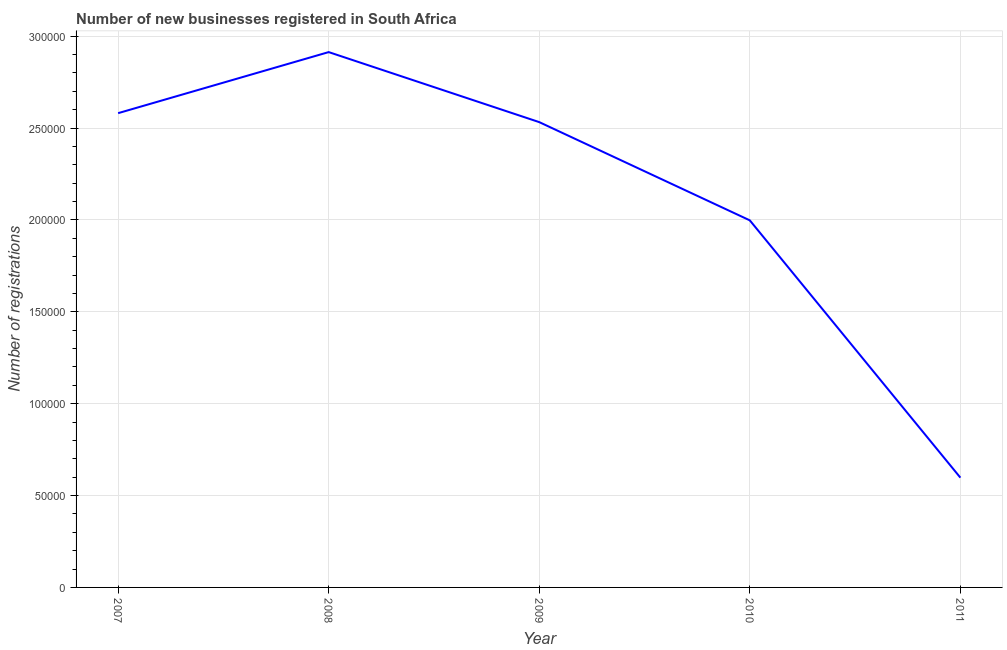What is the number of new business registrations in 2011?
Offer a terse response. 5.97e+04. Across all years, what is the maximum number of new business registrations?
Make the answer very short. 2.91e+05. Across all years, what is the minimum number of new business registrations?
Offer a terse response. 5.97e+04. What is the sum of the number of new business registrations?
Provide a succinct answer. 1.06e+06. What is the difference between the number of new business registrations in 2008 and 2010?
Your response must be concise. 9.16e+04. What is the average number of new business registrations per year?
Provide a short and direct response. 2.12e+05. What is the median number of new business registrations?
Give a very brief answer. 2.53e+05. In how many years, is the number of new business registrations greater than 280000 ?
Your answer should be compact. 1. What is the ratio of the number of new business registrations in 2007 to that in 2009?
Make the answer very short. 1.02. Is the number of new business registrations in 2007 less than that in 2009?
Keep it short and to the point. No. Is the difference between the number of new business registrations in 2009 and 2011 greater than the difference between any two years?
Ensure brevity in your answer.  No. What is the difference between the highest and the second highest number of new business registrations?
Provide a short and direct response. 3.32e+04. What is the difference between the highest and the lowest number of new business registrations?
Provide a succinct answer. 2.32e+05. Does the number of new business registrations monotonically increase over the years?
Ensure brevity in your answer.  No. How many years are there in the graph?
Your response must be concise. 5. What is the difference between two consecutive major ticks on the Y-axis?
Provide a succinct answer. 5.00e+04. Does the graph contain any zero values?
Your response must be concise. No. Does the graph contain grids?
Offer a terse response. Yes. What is the title of the graph?
Your answer should be very brief. Number of new businesses registered in South Africa. What is the label or title of the X-axis?
Make the answer very short. Year. What is the label or title of the Y-axis?
Your response must be concise. Number of registrations. What is the Number of registrations of 2007?
Offer a very short reply. 2.58e+05. What is the Number of registrations of 2008?
Offer a very short reply. 2.91e+05. What is the Number of registrations of 2009?
Offer a terse response. 2.53e+05. What is the Number of registrations in 2010?
Provide a short and direct response. 2.00e+05. What is the Number of registrations of 2011?
Give a very brief answer. 5.97e+04. What is the difference between the Number of registrations in 2007 and 2008?
Give a very brief answer. -3.32e+04. What is the difference between the Number of registrations in 2007 and 2009?
Provide a succinct answer. 4874. What is the difference between the Number of registrations in 2007 and 2010?
Your answer should be very brief. 5.83e+04. What is the difference between the Number of registrations in 2007 and 2011?
Offer a terse response. 1.98e+05. What is the difference between the Number of registrations in 2008 and 2009?
Your answer should be very brief. 3.81e+04. What is the difference between the Number of registrations in 2008 and 2010?
Give a very brief answer. 9.16e+04. What is the difference between the Number of registrations in 2008 and 2011?
Provide a succinct answer. 2.32e+05. What is the difference between the Number of registrations in 2009 and 2010?
Keep it short and to the point. 5.35e+04. What is the difference between the Number of registrations in 2009 and 2011?
Provide a succinct answer. 1.93e+05. What is the difference between the Number of registrations in 2010 and 2011?
Offer a terse response. 1.40e+05. What is the ratio of the Number of registrations in 2007 to that in 2008?
Ensure brevity in your answer.  0.89. What is the ratio of the Number of registrations in 2007 to that in 2009?
Make the answer very short. 1.02. What is the ratio of the Number of registrations in 2007 to that in 2010?
Give a very brief answer. 1.29. What is the ratio of the Number of registrations in 2007 to that in 2011?
Your response must be concise. 4.32. What is the ratio of the Number of registrations in 2008 to that in 2009?
Offer a very short reply. 1.15. What is the ratio of the Number of registrations in 2008 to that in 2010?
Your answer should be very brief. 1.46. What is the ratio of the Number of registrations in 2008 to that in 2011?
Your response must be concise. 4.88. What is the ratio of the Number of registrations in 2009 to that in 2010?
Your answer should be very brief. 1.27. What is the ratio of the Number of registrations in 2009 to that in 2011?
Make the answer very short. 4.24. What is the ratio of the Number of registrations in 2010 to that in 2011?
Your response must be concise. 3.34. 